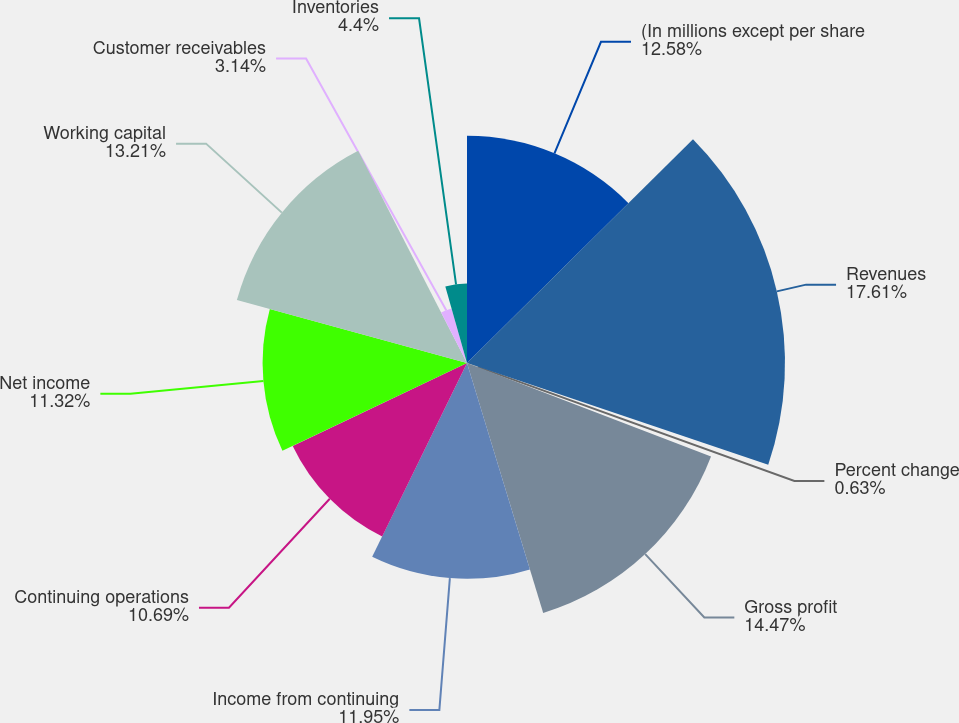Convert chart to OTSL. <chart><loc_0><loc_0><loc_500><loc_500><pie_chart><fcel>(In millions except per share<fcel>Revenues<fcel>Percent change<fcel>Gross profit<fcel>Income from continuing<fcel>Continuing operations<fcel>Net income<fcel>Working capital<fcel>Customer receivables<fcel>Inventories<nl><fcel>12.58%<fcel>17.61%<fcel>0.63%<fcel>14.47%<fcel>11.95%<fcel>10.69%<fcel>11.32%<fcel>13.21%<fcel>3.14%<fcel>4.4%<nl></chart> 